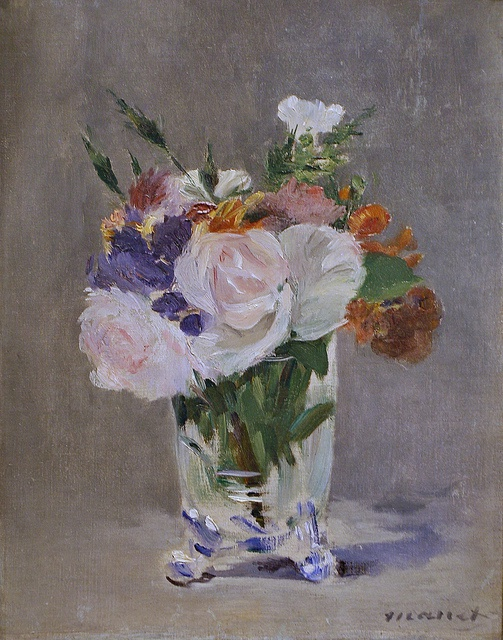Describe the objects in this image and their specific colors. I can see a vase in darkgreen, darkgray, gray, and black tones in this image. 